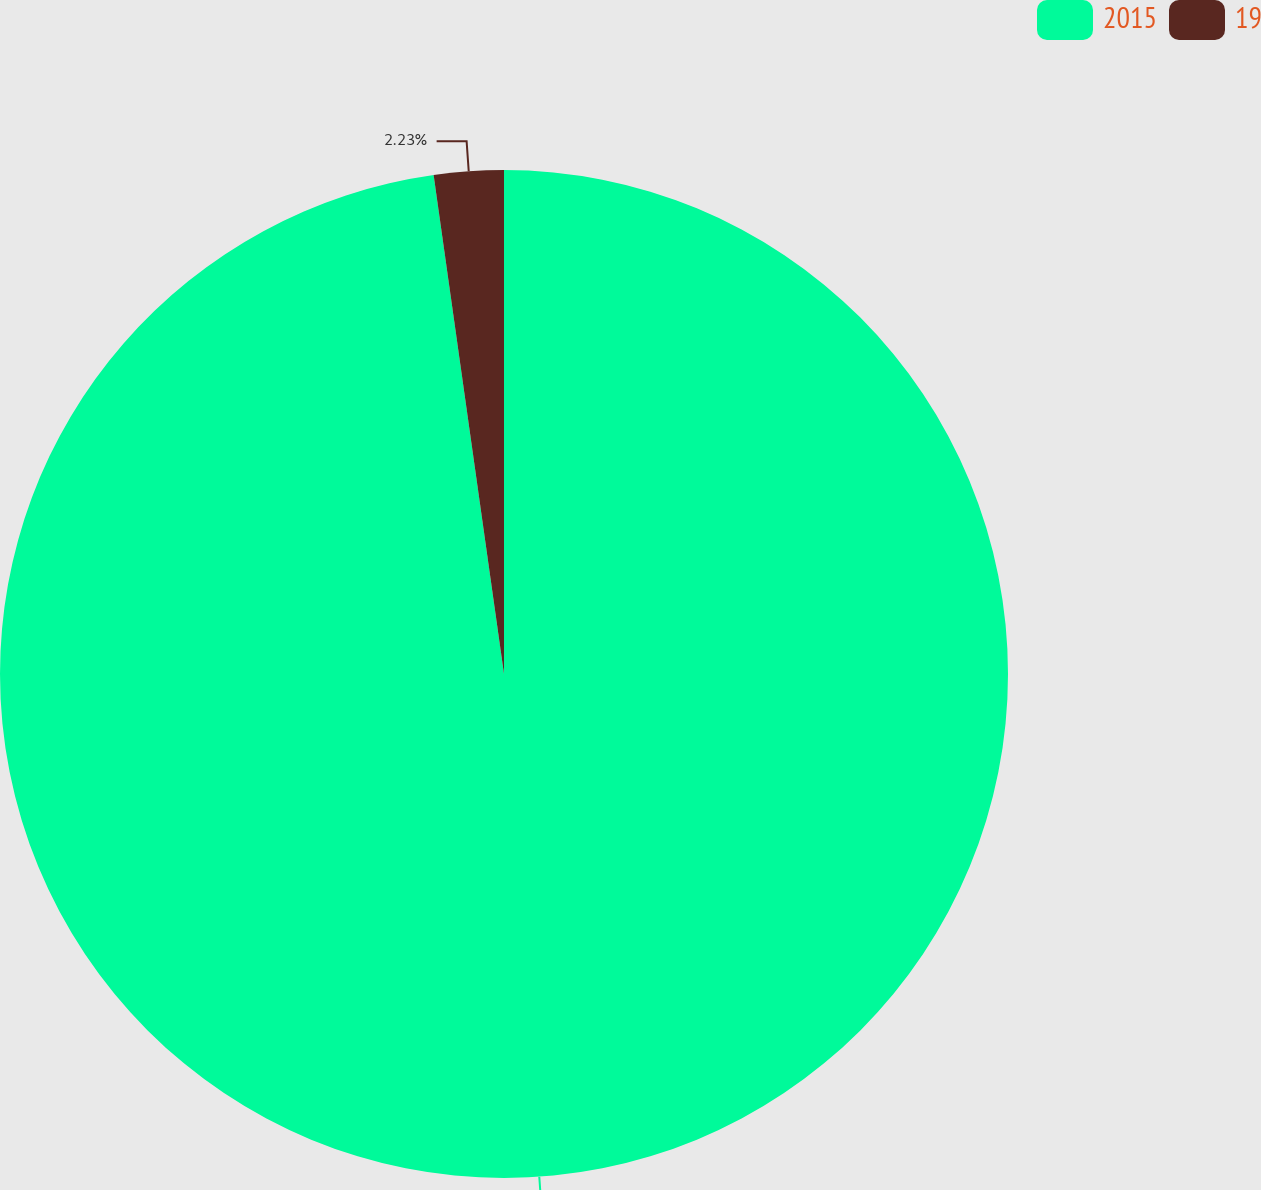Convert chart to OTSL. <chart><loc_0><loc_0><loc_500><loc_500><pie_chart><fcel>2015<fcel>19<nl><fcel>97.77%<fcel>2.23%<nl></chart> 